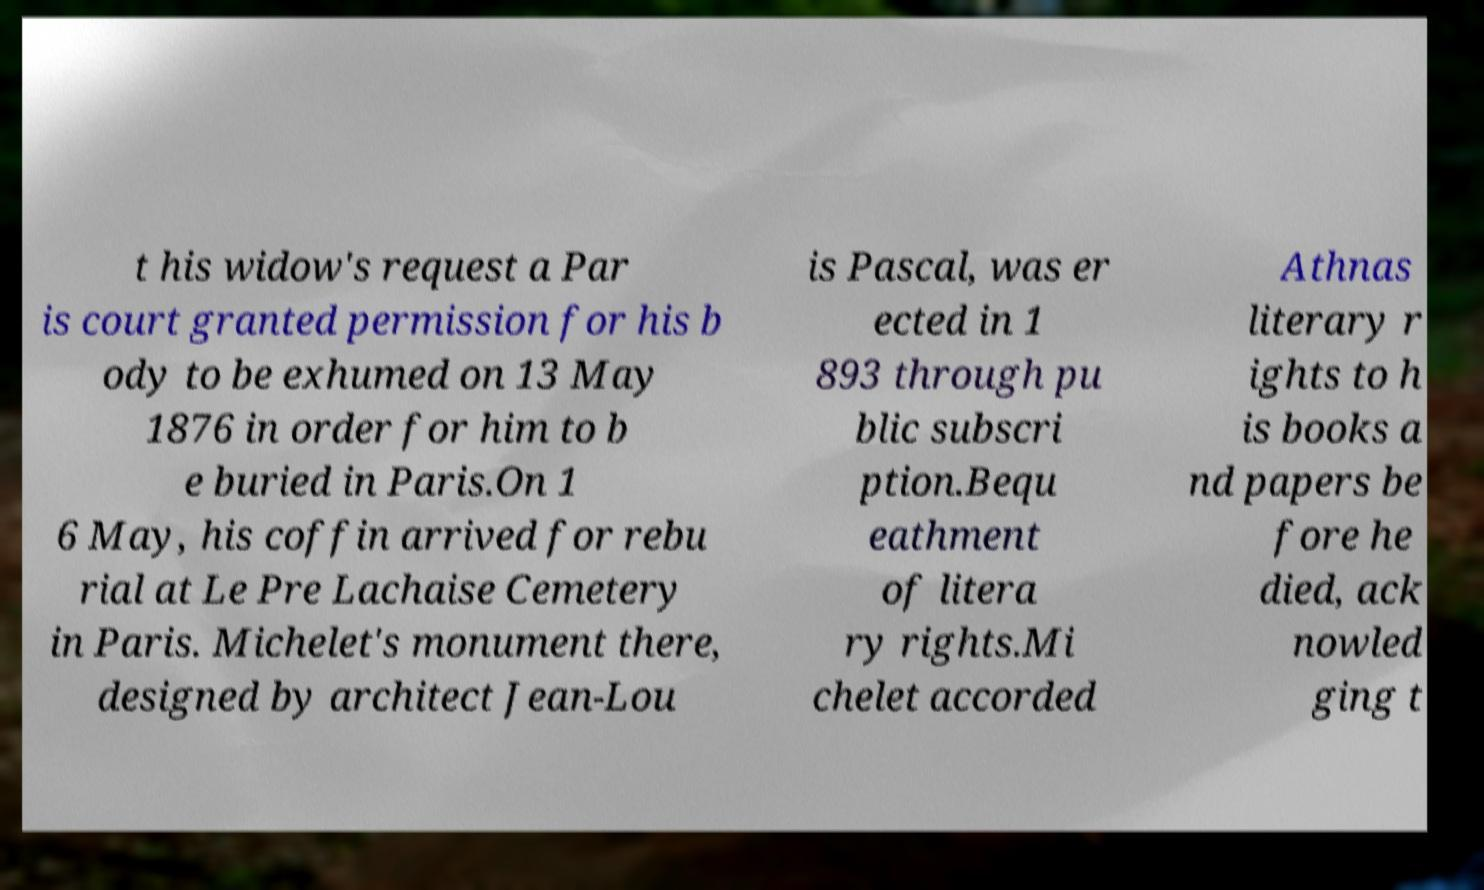Please identify and transcribe the text found in this image. t his widow's request a Par is court granted permission for his b ody to be exhumed on 13 May 1876 in order for him to b e buried in Paris.On 1 6 May, his coffin arrived for rebu rial at Le Pre Lachaise Cemetery in Paris. Michelet's monument there, designed by architect Jean-Lou is Pascal, was er ected in 1 893 through pu blic subscri ption.Bequ eathment of litera ry rights.Mi chelet accorded Athnas literary r ights to h is books a nd papers be fore he died, ack nowled ging t 